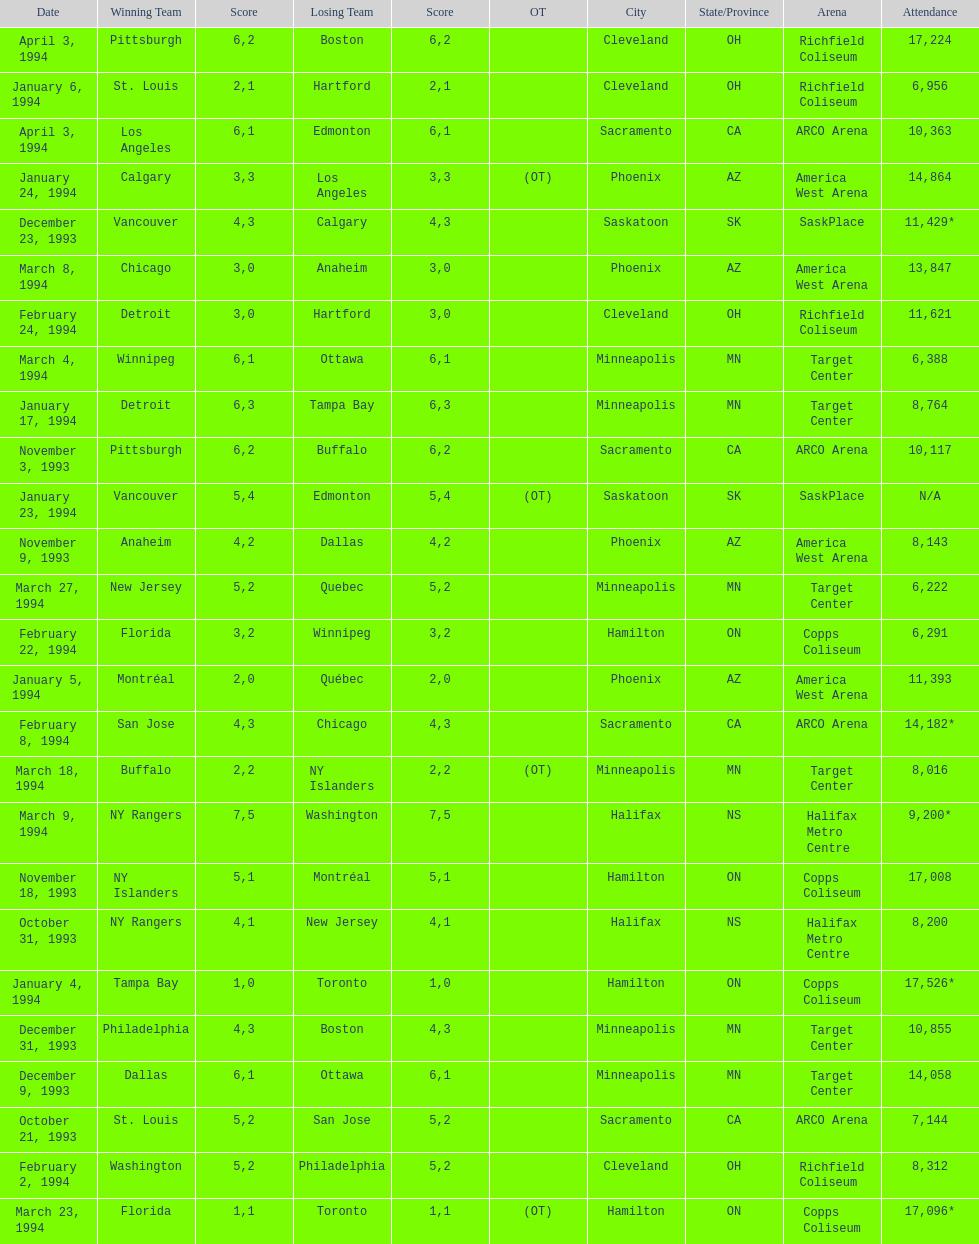When was the first neutral site game to be won by tampa bay? January 4, 1994. 